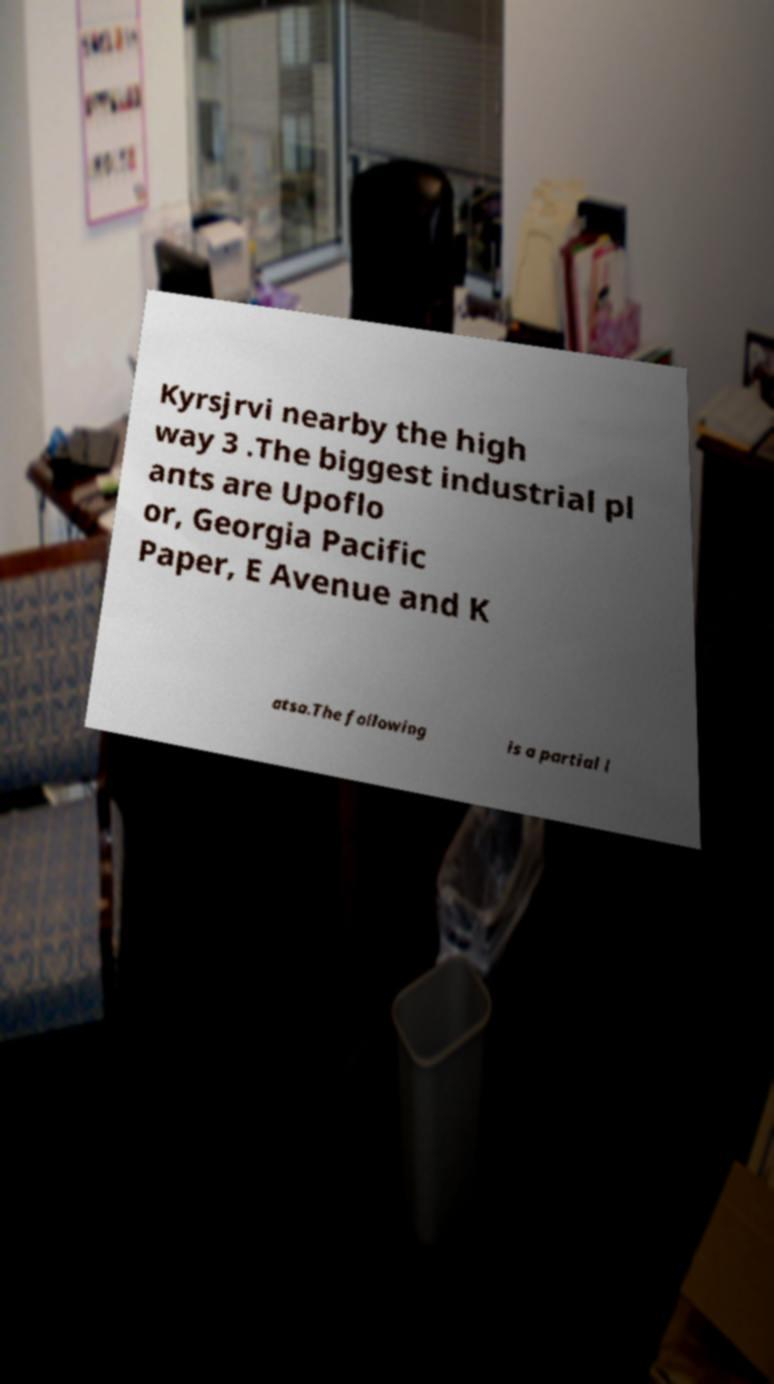There's text embedded in this image that I need extracted. Can you transcribe it verbatim? Kyrsjrvi nearby the high way 3 .The biggest industrial pl ants are Upoflo or, Georgia Pacific Paper, E Avenue and K atsa.The following is a partial l 